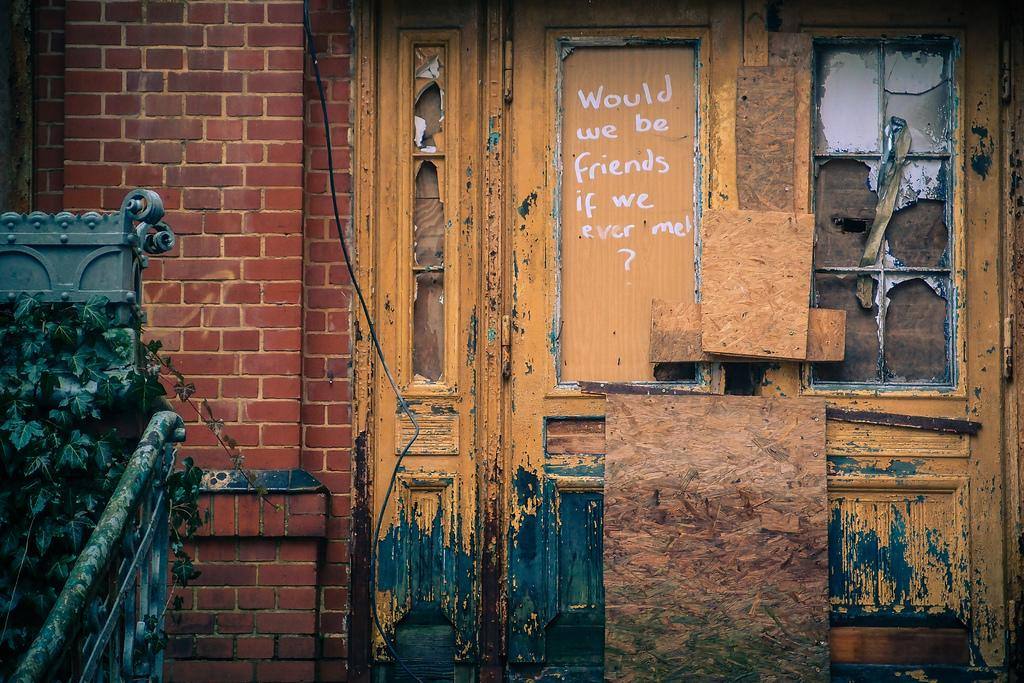What type of structure is present in the image? There is a building in the picture. What material is used for the door of the building? The building has a wooden door. Can you describe any architectural features of the building? There is a railing at the right side of the building. What else can be seen in the image besides the building? There is a plant in the picture. What is written on the door of the building? There is something written on the door. What type of clock is hanging on the wall inside the building? There is no clock visible in the image, as it only shows the exterior of the building. 